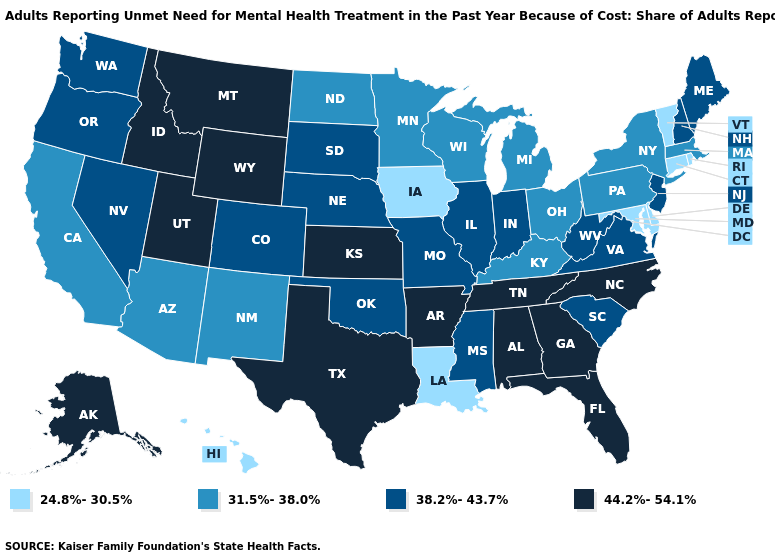What is the value of Illinois?
Concise answer only. 38.2%-43.7%. Among the states that border Nevada , which have the highest value?
Concise answer only. Idaho, Utah. What is the value of Pennsylvania?
Write a very short answer. 31.5%-38.0%. Which states have the highest value in the USA?
Give a very brief answer. Alabama, Alaska, Arkansas, Florida, Georgia, Idaho, Kansas, Montana, North Carolina, Tennessee, Texas, Utah, Wyoming. What is the lowest value in the USA?
Write a very short answer. 24.8%-30.5%. Name the states that have a value in the range 44.2%-54.1%?
Quick response, please. Alabama, Alaska, Arkansas, Florida, Georgia, Idaho, Kansas, Montana, North Carolina, Tennessee, Texas, Utah, Wyoming. Which states have the lowest value in the USA?
Give a very brief answer. Connecticut, Delaware, Hawaii, Iowa, Louisiana, Maryland, Rhode Island, Vermont. Does the map have missing data?
Short answer required. No. Name the states that have a value in the range 24.8%-30.5%?
Concise answer only. Connecticut, Delaware, Hawaii, Iowa, Louisiana, Maryland, Rhode Island, Vermont. Which states have the highest value in the USA?
Answer briefly. Alabama, Alaska, Arkansas, Florida, Georgia, Idaho, Kansas, Montana, North Carolina, Tennessee, Texas, Utah, Wyoming. What is the lowest value in states that border Louisiana?
Give a very brief answer. 38.2%-43.7%. What is the value of Pennsylvania?
Be succinct. 31.5%-38.0%. Name the states that have a value in the range 24.8%-30.5%?
Give a very brief answer. Connecticut, Delaware, Hawaii, Iowa, Louisiana, Maryland, Rhode Island, Vermont. What is the lowest value in the USA?
Keep it brief. 24.8%-30.5%. Does Vermont have the highest value in the USA?
Keep it brief. No. 